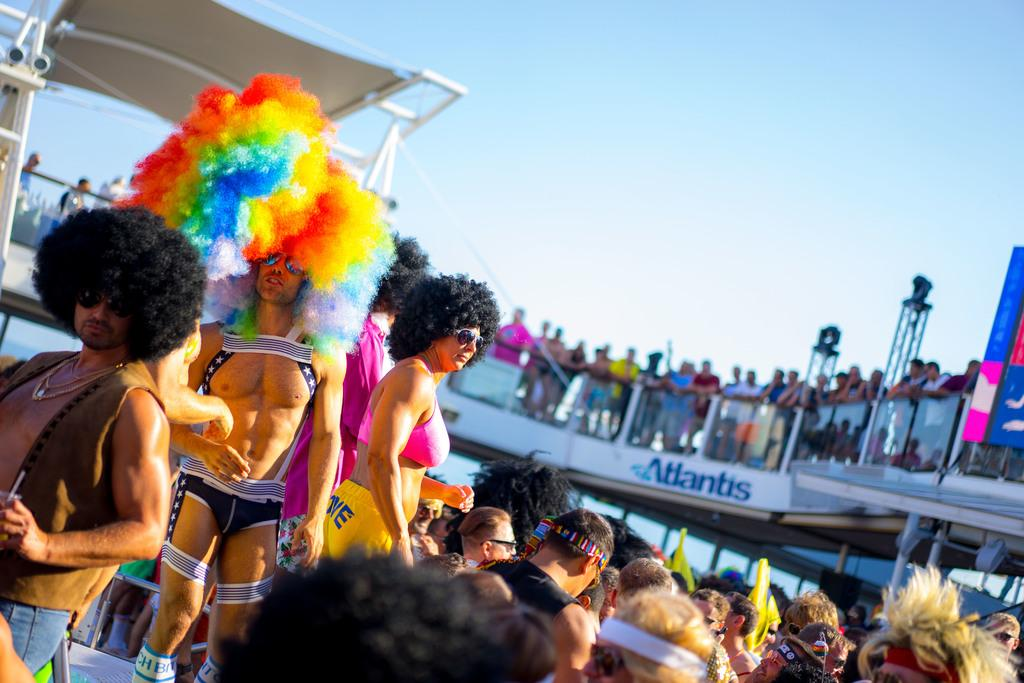Who or what is present in the image? There are people in the image. What else can be seen in the image besides the people? There is a board with text in the image. What is visible at the top of the image? The sky is visible at the top of the image. How many jellyfish are swimming in the sky in the image? There are no jellyfish present in the image, and the sky is not depicted as a body of water where jellyfish could swim. 